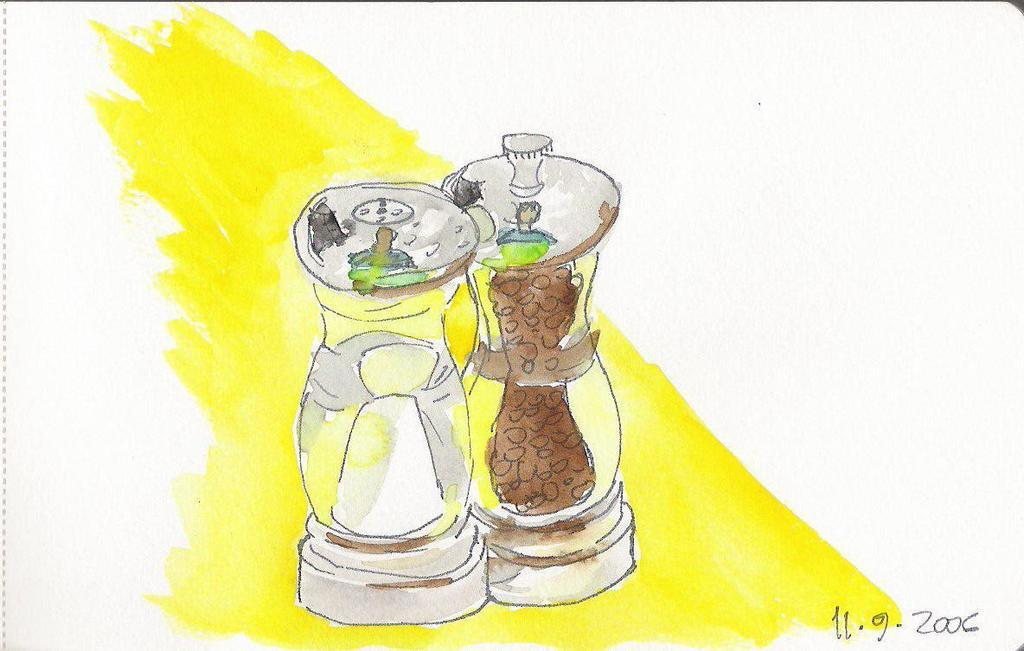Provide a one-sentence caption for the provided image. A painting of a salt shaker and pepper grinder dated 11/9/2006 by the artist. 